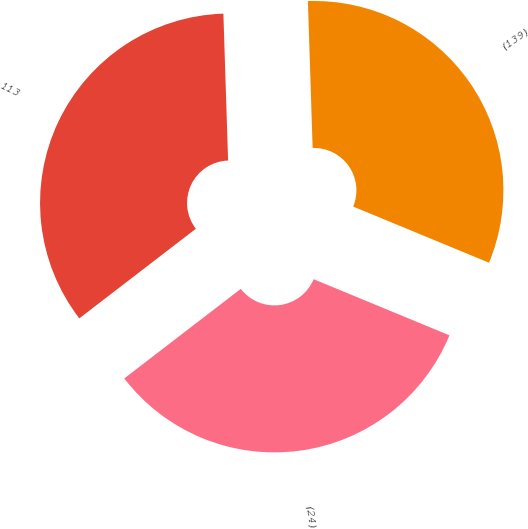Convert chart to OTSL. <chart><loc_0><loc_0><loc_500><loc_500><pie_chart><fcel>(139)<fcel>(24)<fcel>113<nl><fcel>31.75%<fcel>33.33%<fcel>34.92%<nl></chart> 